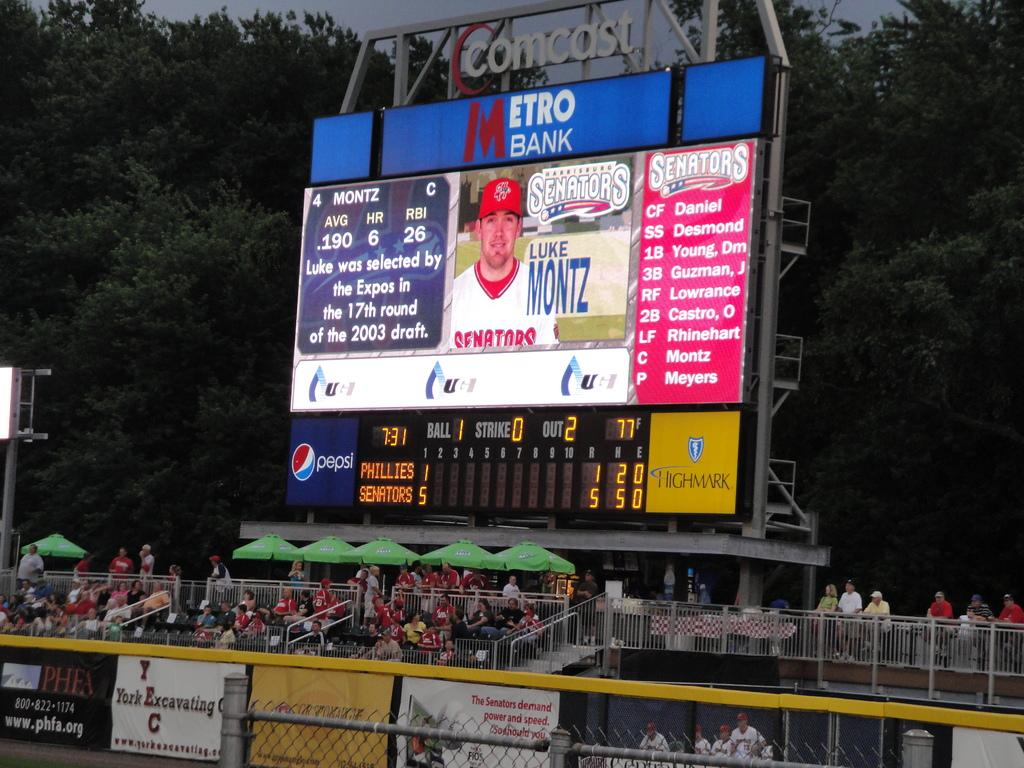<image>
Relay a brief, clear account of the picture shown. A very brief description of Senators player Luke Montz 